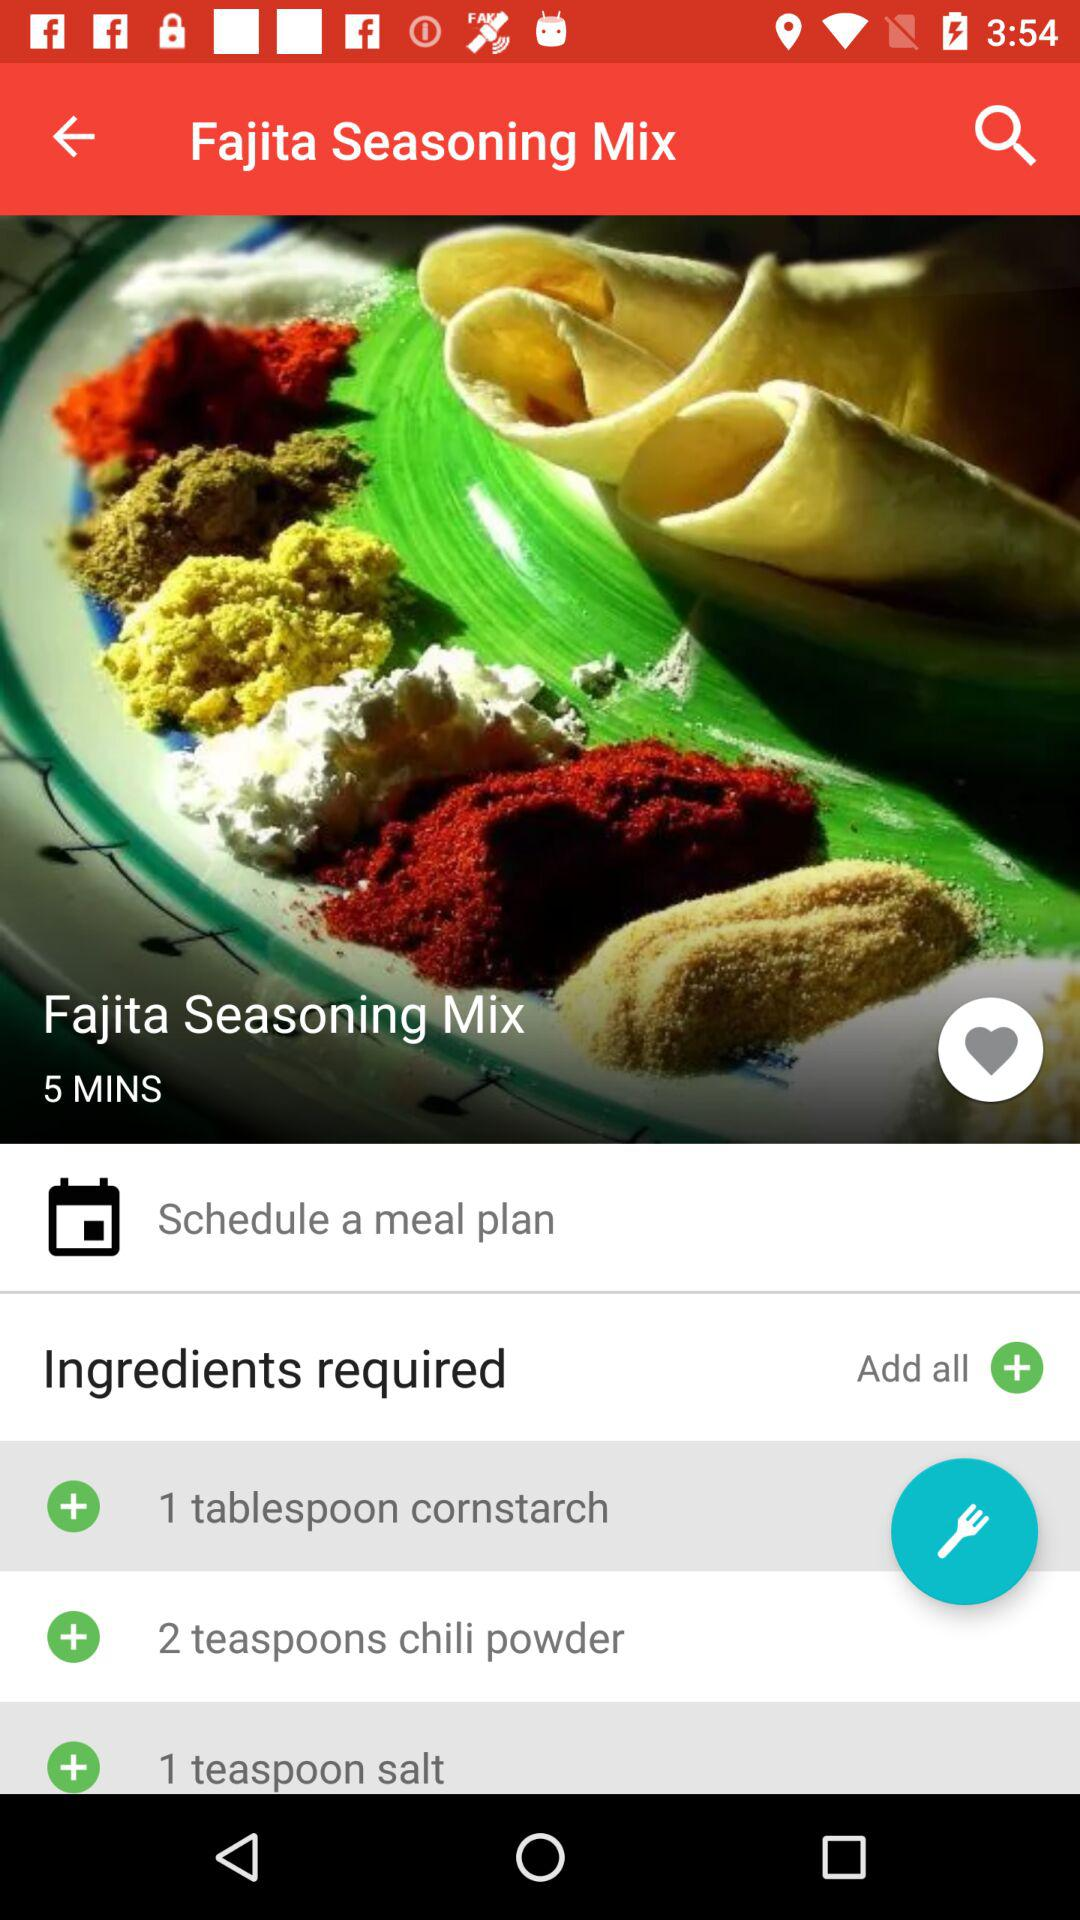How many more ingredients are required than the number of minutes?
Answer the question using a single word or phrase. 2 